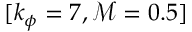<formula> <loc_0><loc_0><loc_500><loc_500>[ k _ { \phi } = 7 , \mathcal { M } = 0 . 5 ]</formula> 